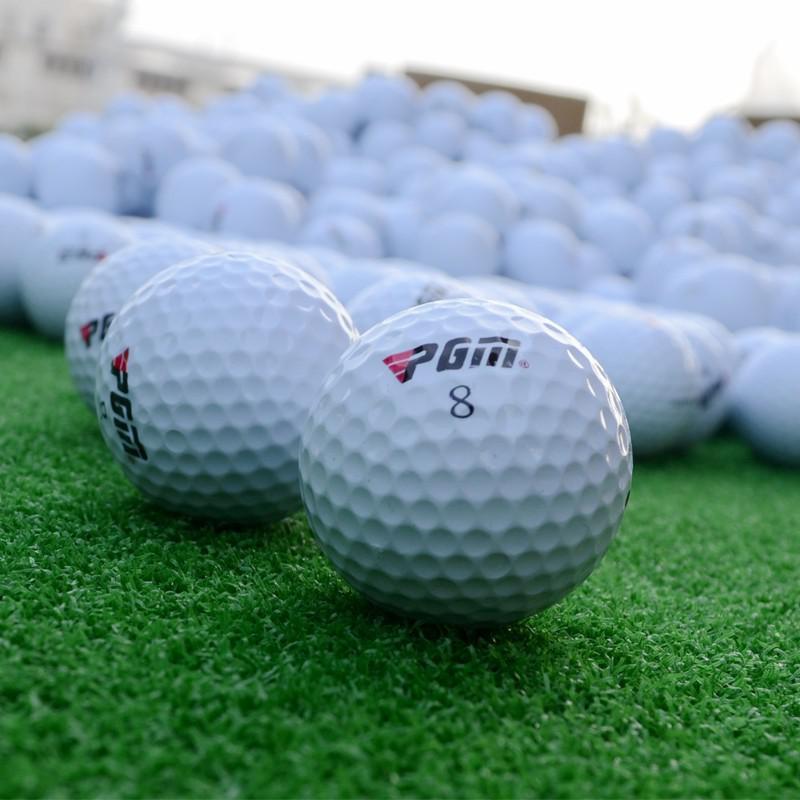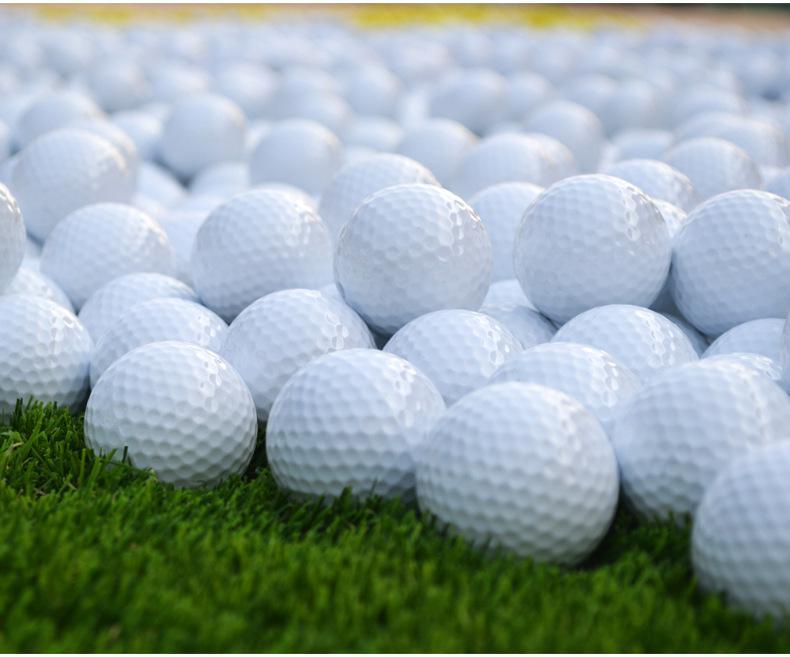The first image is the image on the left, the second image is the image on the right. For the images displayed, is the sentence "Lettering is visible on some of the golf balls in one of the images." factually correct? Answer yes or no. Yes. 